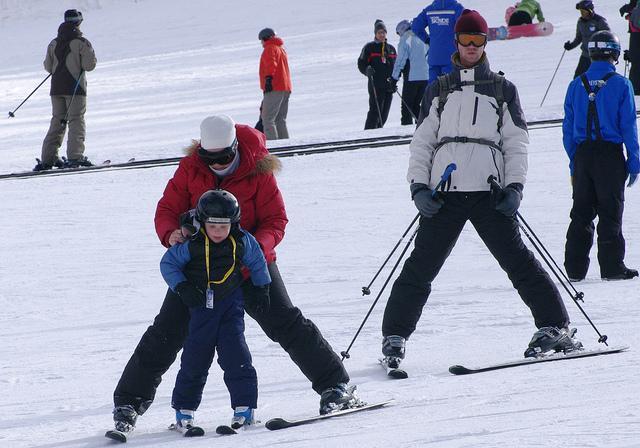How many people are there?
Give a very brief answer. 9. 